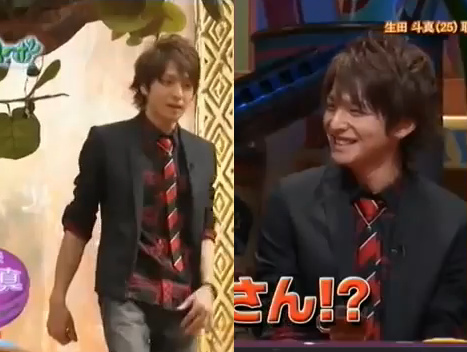Create a whimsical story about this image. Once upon a time in a quirky land, there was a magical television show that transformed dreams into reality. Each guest who appeared on the show was given a chance to speak to the enchanted tree, a mystical entity that could answer any question truthfully. The young man in the black jacket, chosen by fate, walked towards the tree, knowing his life would never be the sharegpt4v/same. As he stood in front of the tree, its leaves glowed, and the audience gasped in awe, waiting for the magic to unfold. The young man smiled, ready to ask the tree about his future adventures in this land of wonder. 